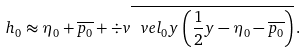Convert formula to latex. <formula><loc_0><loc_0><loc_500><loc_500>h _ { 0 } \approx \eta _ { 0 } + \overline { p _ { 0 } } + \div v \overline { \ v e l _ { 0 } y \left ( \frac { 1 } { 2 } y - \eta _ { 0 } - \overline { p _ { 0 } } \right ) } \, .</formula> 